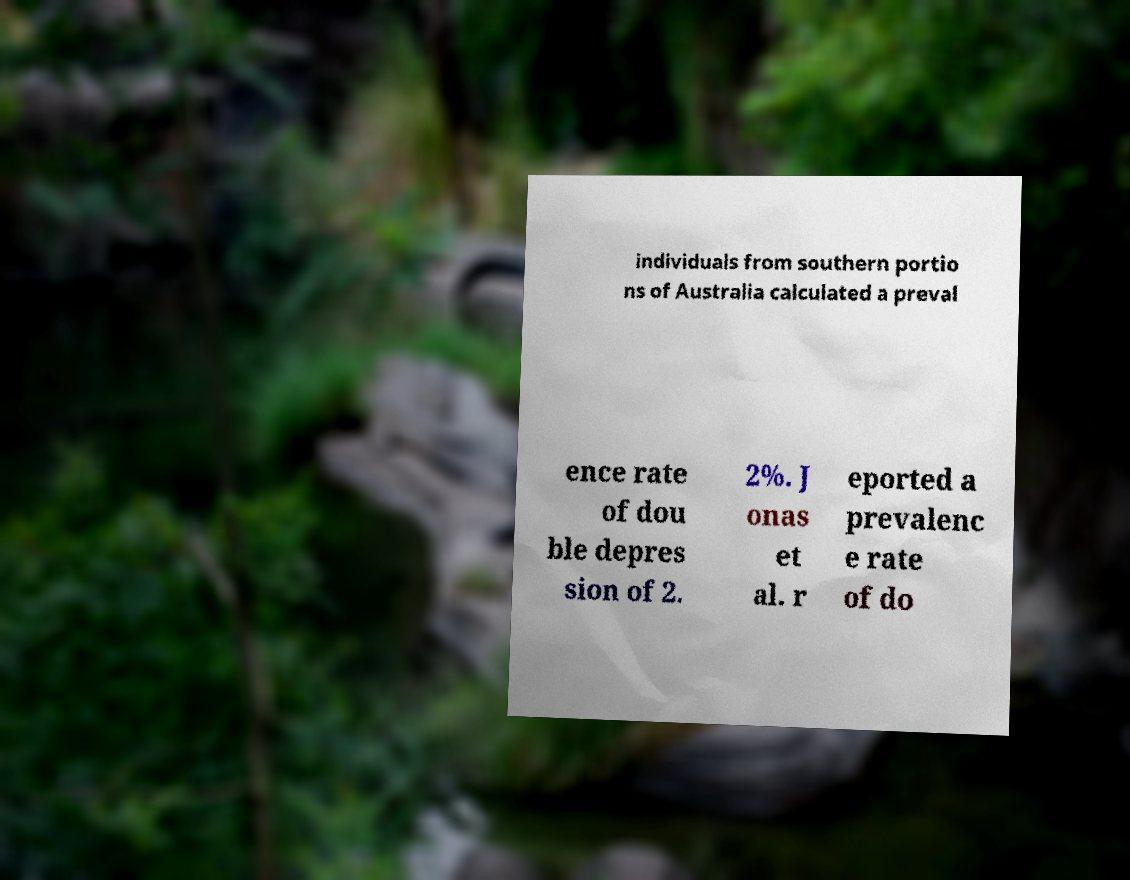Please read and relay the text visible in this image. What does it say? individuals from southern portio ns of Australia calculated a preval ence rate of dou ble depres sion of 2. 2%. J onas et al. r eported a prevalenc e rate of do 